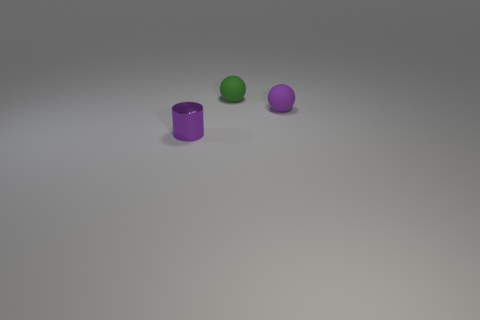Subtract all purple spheres. How many spheres are left? 1 Subtract all balls. How many objects are left? 1 Subtract all gray balls. Subtract all brown blocks. How many balls are left? 2 Subtract all small purple cylinders. Subtract all purple balls. How many objects are left? 1 Add 2 shiny objects. How many shiny objects are left? 3 Add 2 tiny green objects. How many tiny green objects exist? 3 Add 2 matte cylinders. How many objects exist? 5 Subtract 0 brown balls. How many objects are left? 3 